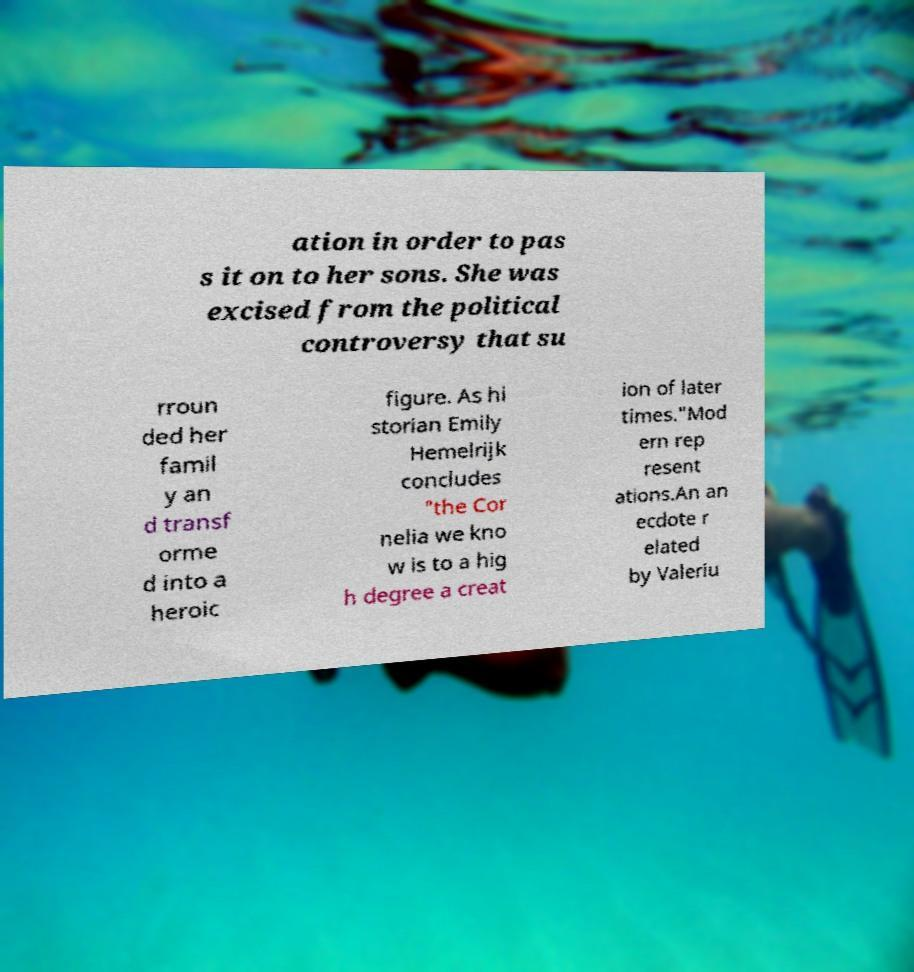What messages or text are displayed in this image? I need them in a readable, typed format. ation in order to pas s it on to her sons. She was excised from the political controversy that su rroun ded her famil y an d transf orme d into a heroic figure. As hi storian Emily Hemelrijk concludes "the Cor nelia we kno w is to a hig h degree a creat ion of later times."Mod ern rep resent ations.An an ecdote r elated by Valeriu 